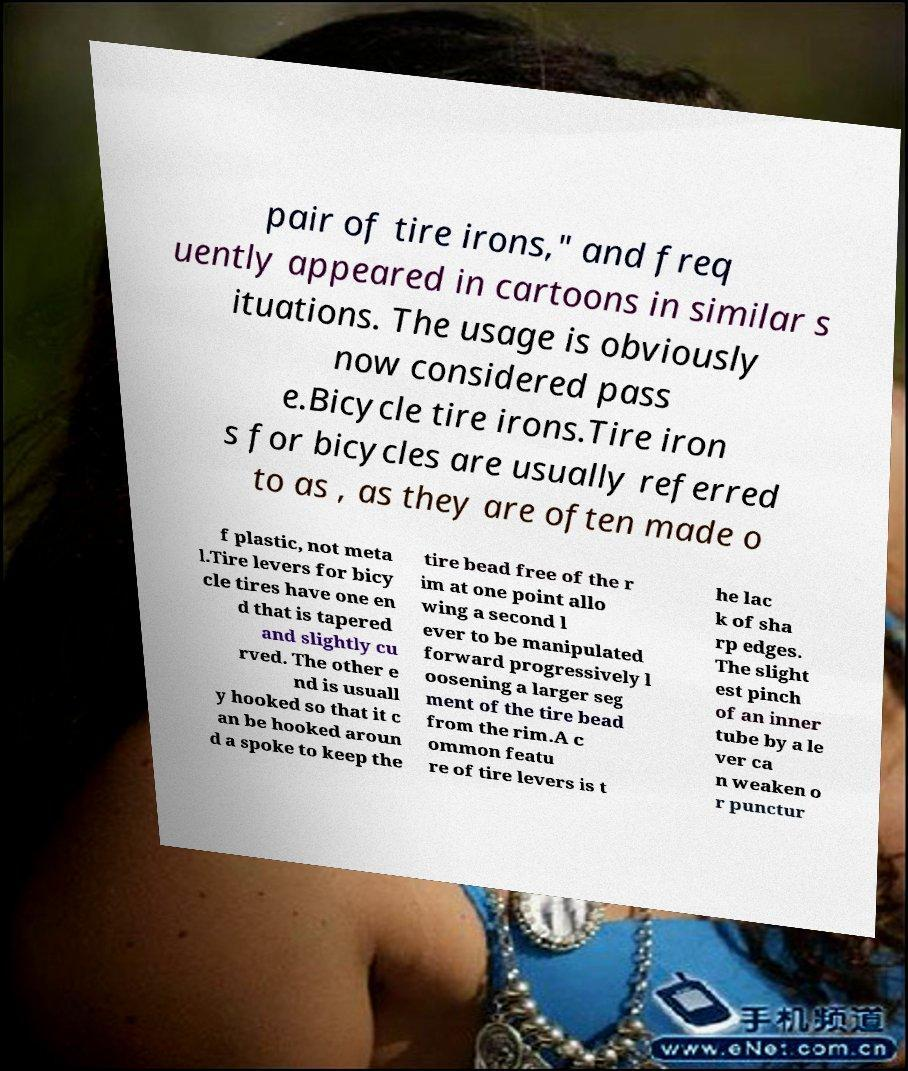Please identify and transcribe the text found in this image. pair of tire irons," and freq uently appeared in cartoons in similar s ituations. The usage is obviously now considered pass e.Bicycle tire irons.Tire iron s for bicycles are usually referred to as , as they are often made o f plastic, not meta l.Tire levers for bicy cle tires have one en d that is tapered and slightly cu rved. The other e nd is usuall y hooked so that it c an be hooked aroun d a spoke to keep the tire bead free of the r im at one point allo wing a second l ever to be manipulated forward progressively l oosening a larger seg ment of the tire bead from the rim.A c ommon featu re of tire levers is t he lac k of sha rp edges. The slight est pinch of an inner tube by a le ver ca n weaken o r punctur 